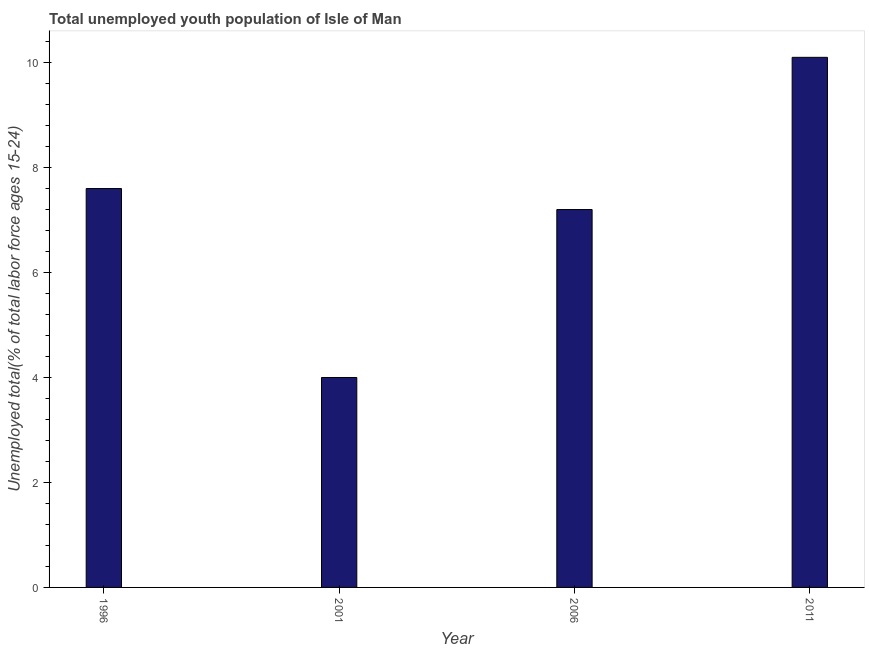Does the graph contain any zero values?
Ensure brevity in your answer.  No. What is the title of the graph?
Your answer should be very brief. Total unemployed youth population of Isle of Man. What is the label or title of the X-axis?
Your response must be concise. Year. What is the label or title of the Y-axis?
Provide a short and direct response. Unemployed total(% of total labor force ages 15-24). What is the unemployed youth in 1996?
Your response must be concise. 7.6. Across all years, what is the maximum unemployed youth?
Keep it short and to the point. 10.1. In which year was the unemployed youth minimum?
Offer a very short reply. 2001. What is the sum of the unemployed youth?
Your answer should be compact. 28.9. What is the difference between the unemployed youth in 1996 and 2001?
Your answer should be very brief. 3.6. What is the average unemployed youth per year?
Your answer should be very brief. 7.22. What is the median unemployed youth?
Your answer should be compact. 7.4. Do a majority of the years between 2001 and 1996 (inclusive) have unemployed youth greater than 0.8 %?
Ensure brevity in your answer.  No. What is the ratio of the unemployed youth in 2006 to that in 2011?
Your answer should be very brief. 0.71. Is the sum of the unemployed youth in 2001 and 2011 greater than the maximum unemployed youth across all years?
Provide a succinct answer. Yes. Are the values on the major ticks of Y-axis written in scientific E-notation?
Offer a terse response. No. What is the Unemployed total(% of total labor force ages 15-24) in 1996?
Ensure brevity in your answer.  7.6. What is the Unemployed total(% of total labor force ages 15-24) in 2006?
Your answer should be very brief. 7.2. What is the Unemployed total(% of total labor force ages 15-24) in 2011?
Provide a succinct answer. 10.1. What is the difference between the Unemployed total(% of total labor force ages 15-24) in 1996 and 2001?
Your answer should be very brief. 3.6. What is the difference between the Unemployed total(% of total labor force ages 15-24) in 1996 and 2011?
Provide a succinct answer. -2.5. What is the difference between the Unemployed total(% of total labor force ages 15-24) in 2001 and 2011?
Give a very brief answer. -6.1. What is the ratio of the Unemployed total(% of total labor force ages 15-24) in 1996 to that in 2001?
Offer a terse response. 1.9. What is the ratio of the Unemployed total(% of total labor force ages 15-24) in 1996 to that in 2006?
Offer a terse response. 1.06. What is the ratio of the Unemployed total(% of total labor force ages 15-24) in 1996 to that in 2011?
Provide a succinct answer. 0.75. What is the ratio of the Unemployed total(% of total labor force ages 15-24) in 2001 to that in 2006?
Make the answer very short. 0.56. What is the ratio of the Unemployed total(% of total labor force ages 15-24) in 2001 to that in 2011?
Provide a short and direct response. 0.4. What is the ratio of the Unemployed total(% of total labor force ages 15-24) in 2006 to that in 2011?
Give a very brief answer. 0.71. 